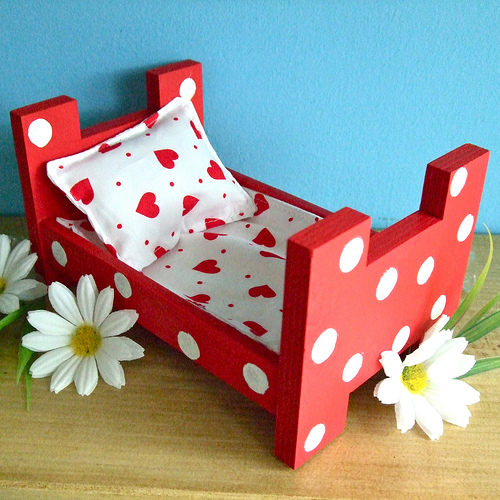<image>
Is the flower under the bed? Yes. The flower is positioned underneath the bed, with the bed above it in the vertical space. Where is the bed in relation to the flower? Is it in front of the flower? No. The bed is not in front of the flower. The spatial positioning shows a different relationship between these objects. 